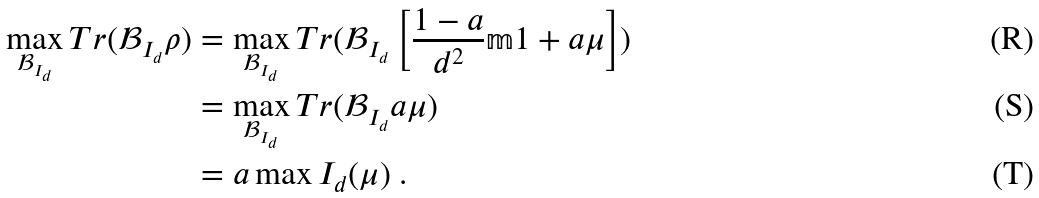Convert formula to latex. <formula><loc_0><loc_0><loc_500><loc_500>\max _ { \mathcal { B } _ { I _ { d } } } T r ( \mathcal { B } _ { I _ { d } } \rho ) & = \max _ { \mathcal { B } _ { I _ { d } } } T r ( \mathcal { B } _ { I _ { d } } \left [ \frac { 1 - a } { d ^ { 2 } } \mathbb { m } { 1 } + a \mu \right ] ) \\ & = \max _ { \mathcal { B } _ { I _ { d } } } T r ( \mathcal { B } _ { I _ { d } } a \mu ) \\ & = a \max I _ { d } ( \mu ) \ .</formula> 